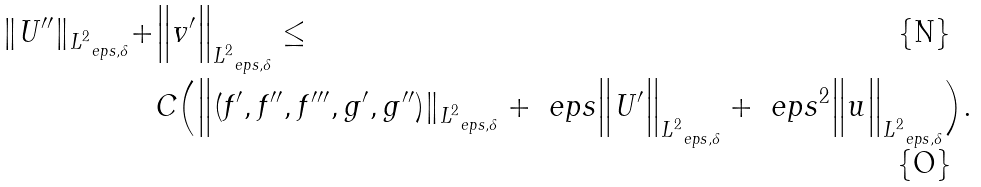Convert formula to latex. <formula><loc_0><loc_0><loc_500><loc_500>\| U ^ { \prime \prime } \| _ { L ^ { 2 } _ { \ e p s , \delta } } + & \Big \| v ^ { \prime } \Big \| _ { L ^ { 2 } _ { \ e p s , \delta } } \leq \\ & C \Big ( \Big \| ( f ^ { \prime } , f ^ { \prime \prime } , f ^ { \prime \prime \prime } , g ^ { \prime } , g ^ { \prime \prime } ) \| _ { L ^ { 2 } _ { \ e p s , \delta } } + \ e p s \Big \| U ^ { \prime } \Big \| _ { L ^ { 2 } _ { \ e p s , \delta } } + \ e p s ^ { 2 } \Big \| u \Big \| _ { L ^ { 2 } _ { \ e p s , \delta } } \Big ) .</formula> 